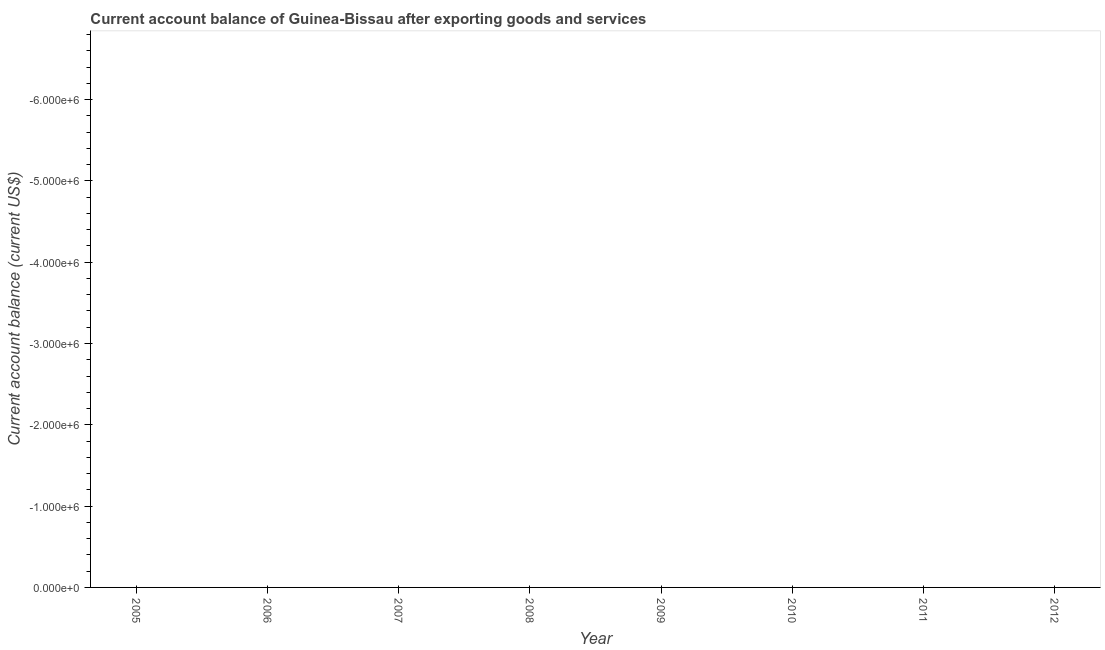What is the current account balance in 2012?
Keep it short and to the point. 0. What is the sum of the current account balance?
Offer a terse response. 0. What is the average current account balance per year?
Offer a terse response. 0. In how many years, is the current account balance greater than -200000 US$?
Your answer should be very brief. 0. In how many years, is the current account balance greater than the average current account balance taken over all years?
Your answer should be compact. 0. Does the current account balance monotonically increase over the years?
Offer a very short reply. No. How many lines are there?
Ensure brevity in your answer.  0. How many years are there in the graph?
Your answer should be very brief. 8. What is the difference between two consecutive major ticks on the Y-axis?
Provide a succinct answer. 1.00e+06. Are the values on the major ticks of Y-axis written in scientific E-notation?
Provide a short and direct response. Yes. Does the graph contain any zero values?
Keep it short and to the point. Yes. What is the title of the graph?
Your answer should be very brief. Current account balance of Guinea-Bissau after exporting goods and services. What is the label or title of the Y-axis?
Make the answer very short. Current account balance (current US$). What is the Current account balance (current US$) of 2006?
Your response must be concise. 0. What is the Current account balance (current US$) in 2009?
Your answer should be compact. 0. What is the Current account balance (current US$) in 2010?
Keep it short and to the point. 0. What is the Current account balance (current US$) in 2012?
Offer a very short reply. 0. 